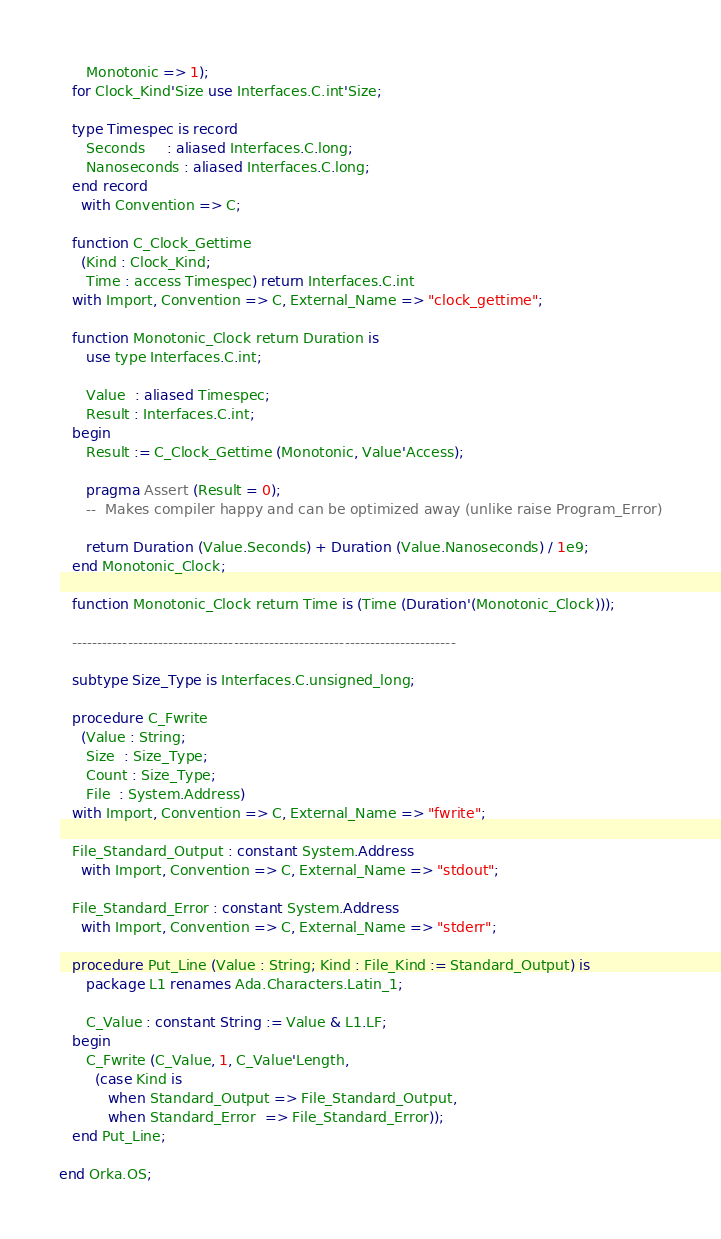Convert code to text. <code><loc_0><loc_0><loc_500><loc_500><_Ada_>      Monotonic => 1);
   for Clock_Kind'Size use Interfaces.C.int'Size;

   type Timespec is record
      Seconds     : aliased Interfaces.C.long;
      Nanoseconds : aliased Interfaces.C.long;
   end record
     with Convention => C;

   function C_Clock_Gettime
     (Kind : Clock_Kind;
      Time : access Timespec) return Interfaces.C.int
   with Import, Convention => C, External_Name => "clock_gettime";

   function Monotonic_Clock return Duration is
      use type Interfaces.C.int;

      Value  : aliased Timespec;
      Result : Interfaces.C.int;
   begin
      Result := C_Clock_Gettime (Monotonic, Value'Access);

      pragma Assert (Result = 0);
      --  Makes compiler happy and can be optimized away (unlike raise Program_Error)

      return Duration (Value.Seconds) + Duration (Value.Nanoseconds) / 1e9;
   end Monotonic_Clock;

   function Monotonic_Clock return Time is (Time (Duration'(Monotonic_Clock)));

   ----------------------------------------------------------------------------

   subtype Size_Type is Interfaces.C.unsigned_long;

   procedure C_Fwrite
     (Value : String;
      Size  : Size_Type;
      Count : Size_Type;
      File  : System.Address)
   with Import, Convention => C, External_Name => "fwrite";

   File_Standard_Output : constant System.Address
     with Import, Convention => C, External_Name => "stdout";

   File_Standard_Error : constant System.Address
     with Import, Convention => C, External_Name => "stderr";

   procedure Put_Line (Value : String; Kind : File_Kind := Standard_Output) is
      package L1 renames Ada.Characters.Latin_1;

      C_Value : constant String := Value & L1.LF;
   begin
      C_Fwrite (C_Value, 1, C_Value'Length,
        (case Kind is
           when Standard_Output => File_Standard_Output,
           when Standard_Error  => File_Standard_Error));
   end Put_Line;

end Orka.OS;
</code> 